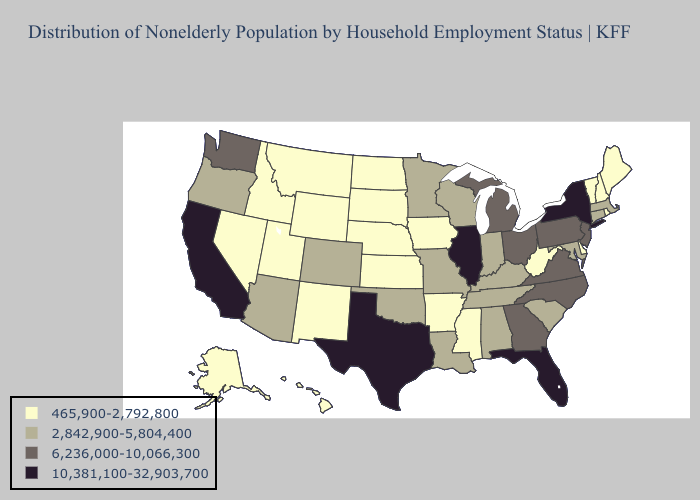Among the states that border Michigan , does Ohio have the lowest value?
Give a very brief answer. No. Does Delaware have a higher value than Nevada?
Short answer required. No. Which states hav the highest value in the Northeast?
Concise answer only. New York. What is the highest value in the Northeast ?
Keep it brief. 10,381,100-32,903,700. Which states hav the highest value in the South?
Keep it brief. Florida, Texas. What is the highest value in the West ?
Concise answer only. 10,381,100-32,903,700. What is the lowest value in states that border New Mexico?
Give a very brief answer. 465,900-2,792,800. What is the value of Nebraska?
Quick response, please. 465,900-2,792,800. What is the lowest value in the MidWest?
Short answer required. 465,900-2,792,800. What is the value of Hawaii?
Write a very short answer. 465,900-2,792,800. Does Delaware have a lower value than Virginia?
Quick response, please. Yes. Among the states that border Iowa , which have the lowest value?
Be succinct. Nebraska, South Dakota. What is the value of Maine?
Be succinct. 465,900-2,792,800. What is the lowest value in the USA?
Be succinct. 465,900-2,792,800. Name the states that have a value in the range 2,842,900-5,804,400?
Be succinct. Alabama, Arizona, Colorado, Connecticut, Indiana, Kentucky, Louisiana, Maryland, Massachusetts, Minnesota, Missouri, Oklahoma, Oregon, South Carolina, Tennessee, Wisconsin. 